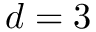<formula> <loc_0><loc_0><loc_500><loc_500>d = 3</formula> 